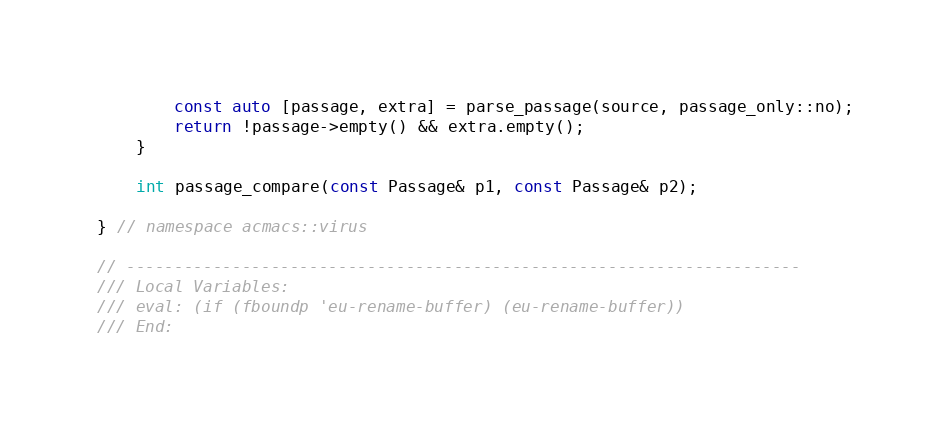Convert code to text. <code><loc_0><loc_0><loc_500><loc_500><_C++_>        const auto [passage, extra] = parse_passage(source, passage_only::no);
        return !passage->empty() && extra.empty();
    }

    int passage_compare(const Passage& p1, const Passage& p2);

} // namespace acmacs::virus

// ----------------------------------------------------------------------
/// Local Variables:
/// eval: (if (fboundp 'eu-rename-buffer) (eu-rename-buffer))
/// End:
</code> 